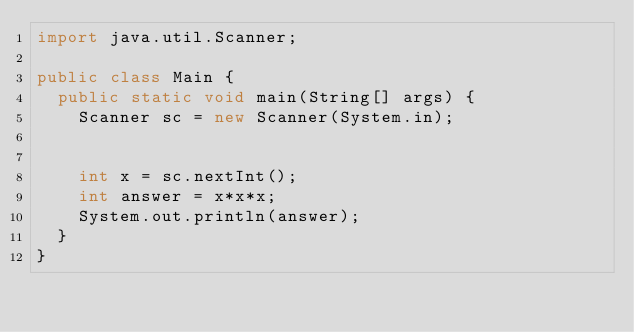<code> <loc_0><loc_0><loc_500><loc_500><_Java_>import java.util.Scanner;

public class Main {
	public static void main(String[] args) {
		Scanner sc = new Scanner(System.in);


		int x = sc.nextInt();
		int answer = x*x*x;
		System.out.println(answer);
	}
}</code> 